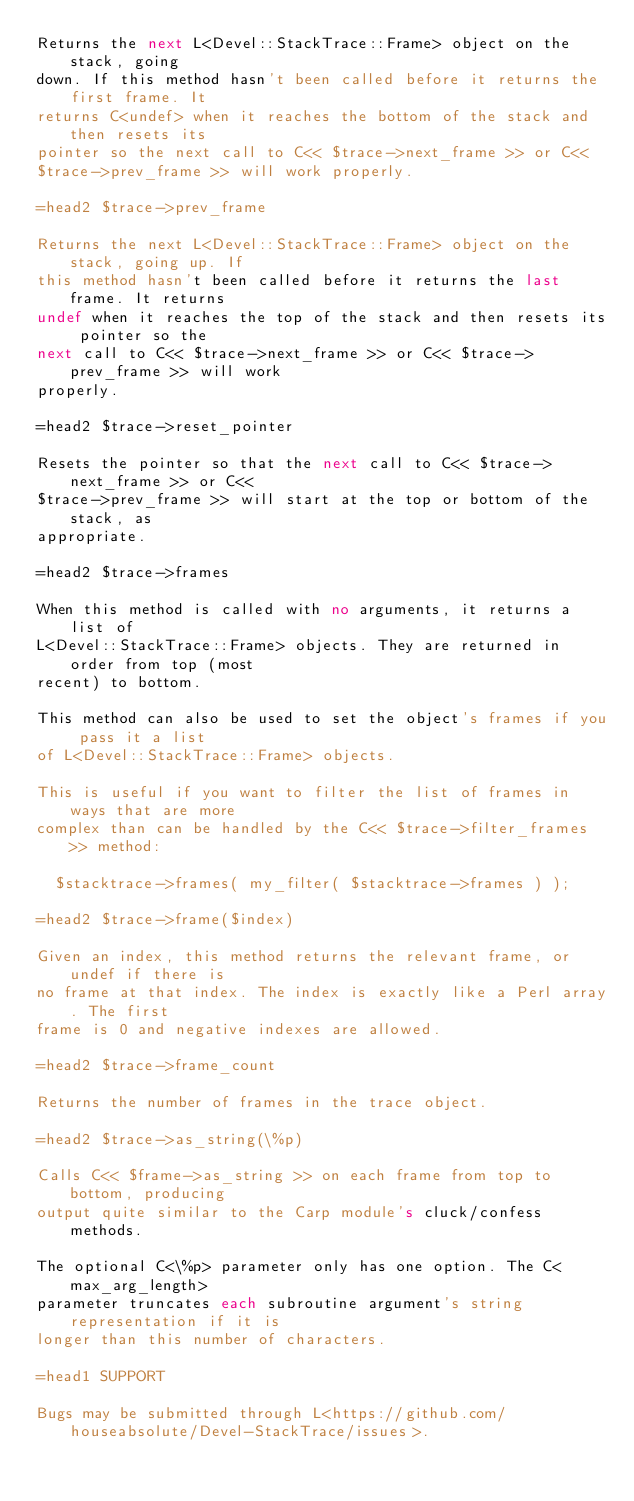<code> <loc_0><loc_0><loc_500><loc_500><_Perl_>Returns the next L<Devel::StackTrace::Frame> object on the stack, going
down. If this method hasn't been called before it returns the first frame. It
returns C<undef> when it reaches the bottom of the stack and then resets its
pointer so the next call to C<< $trace->next_frame >> or C<<
$trace->prev_frame >> will work properly.

=head2 $trace->prev_frame

Returns the next L<Devel::StackTrace::Frame> object on the stack, going up. If
this method hasn't been called before it returns the last frame. It returns
undef when it reaches the top of the stack and then resets its pointer so the
next call to C<< $trace->next_frame >> or C<< $trace->prev_frame >> will work
properly.

=head2 $trace->reset_pointer

Resets the pointer so that the next call to C<< $trace->next_frame >> or C<<
$trace->prev_frame >> will start at the top or bottom of the stack, as
appropriate.

=head2 $trace->frames

When this method is called with no arguments, it returns a list of
L<Devel::StackTrace::Frame> objects. They are returned in order from top (most
recent) to bottom.

This method can also be used to set the object's frames if you pass it a list
of L<Devel::StackTrace::Frame> objects.

This is useful if you want to filter the list of frames in ways that are more
complex than can be handled by the C<< $trace->filter_frames >> method:

  $stacktrace->frames( my_filter( $stacktrace->frames ) );

=head2 $trace->frame($index)

Given an index, this method returns the relevant frame, or undef if there is
no frame at that index. The index is exactly like a Perl array. The first
frame is 0 and negative indexes are allowed.

=head2 $trace->frame_count

Returns the number of frames in the trace object.

=head2 $trace->as_string(\%p)

Calls C<< $frame->as_string >> on each frame from top to bottom, producing
output quite similar to the Carp module's cluck/confess methods.

The optional C<\%p> parameter only has one option. The C<max_arg_length>
parameter truncates each subroutine argument's string representation if it is
longer than this number of characters.

=head1 SUPPORT

Bugs may be submitted through L<https://github.com/houseabsolute/Devel-StackTrace/issues>.
</code> 